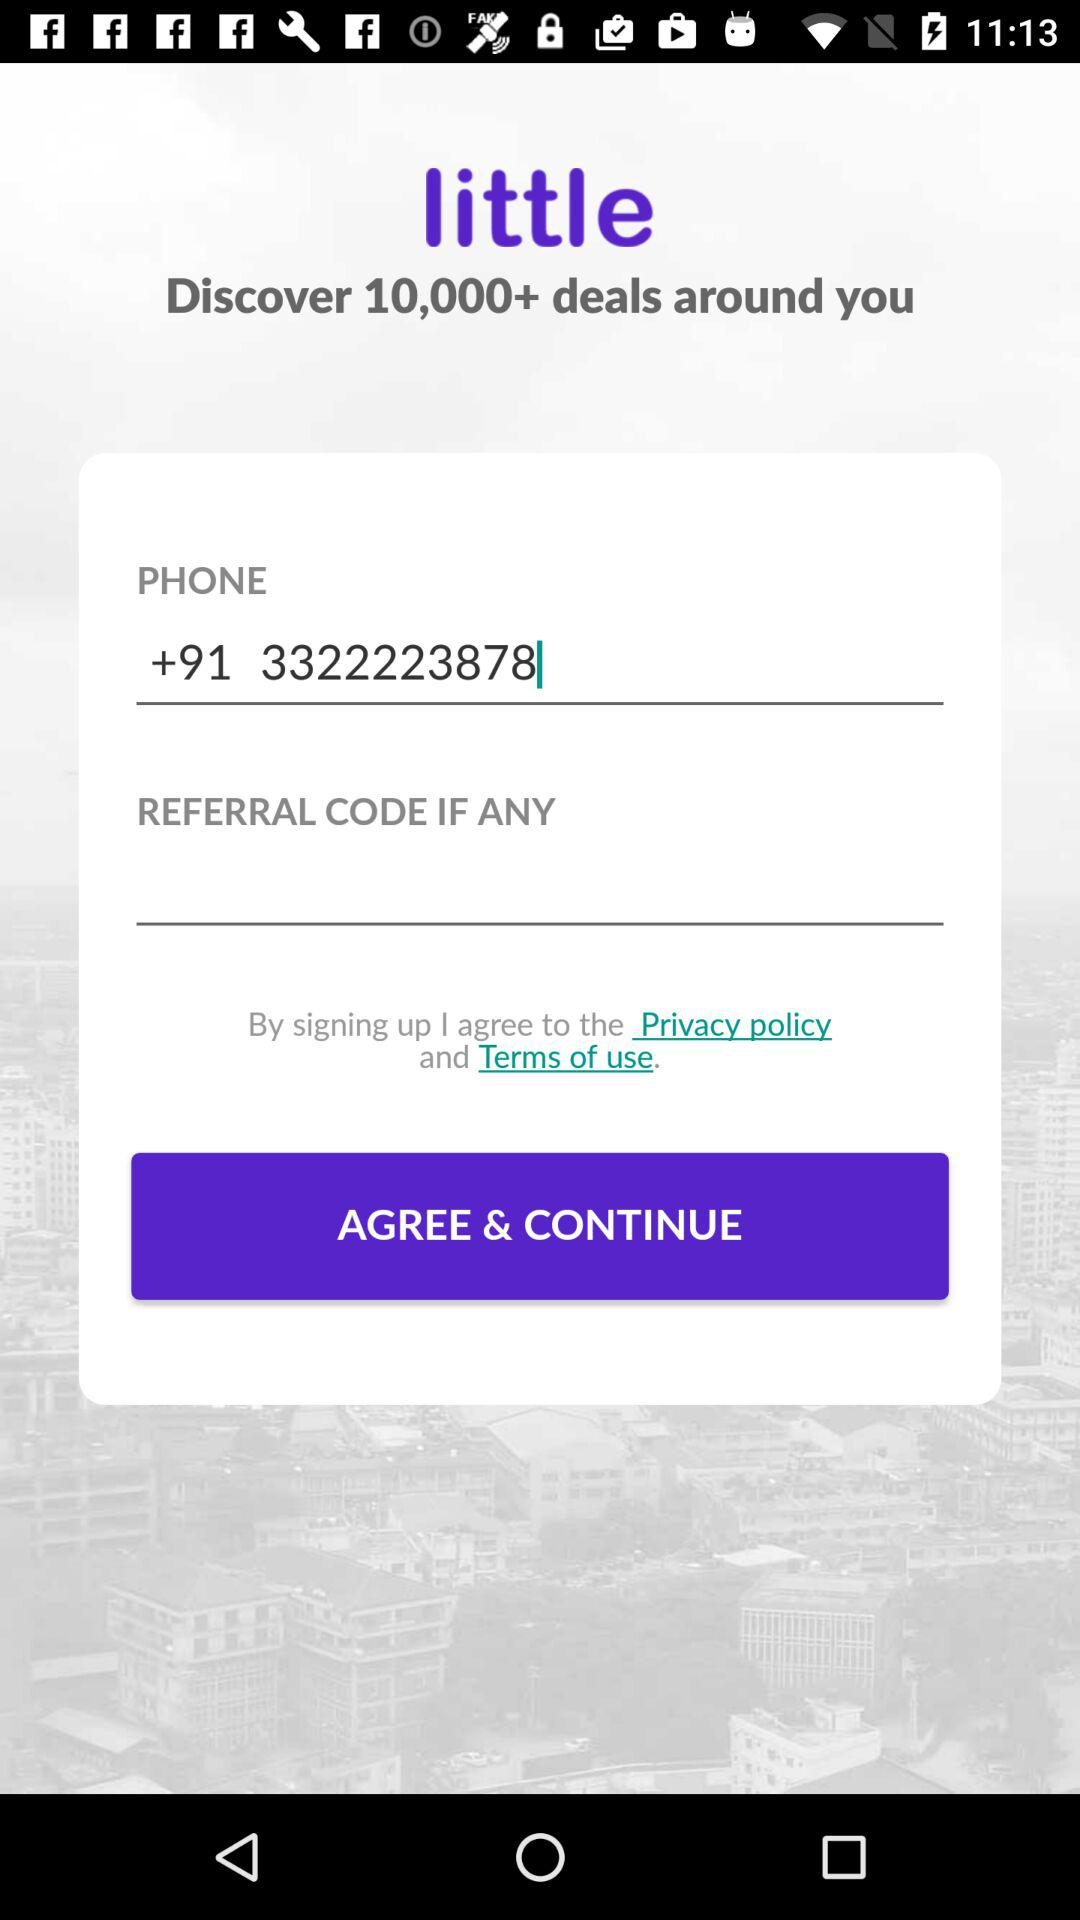What is the application name? The application name is "little". 